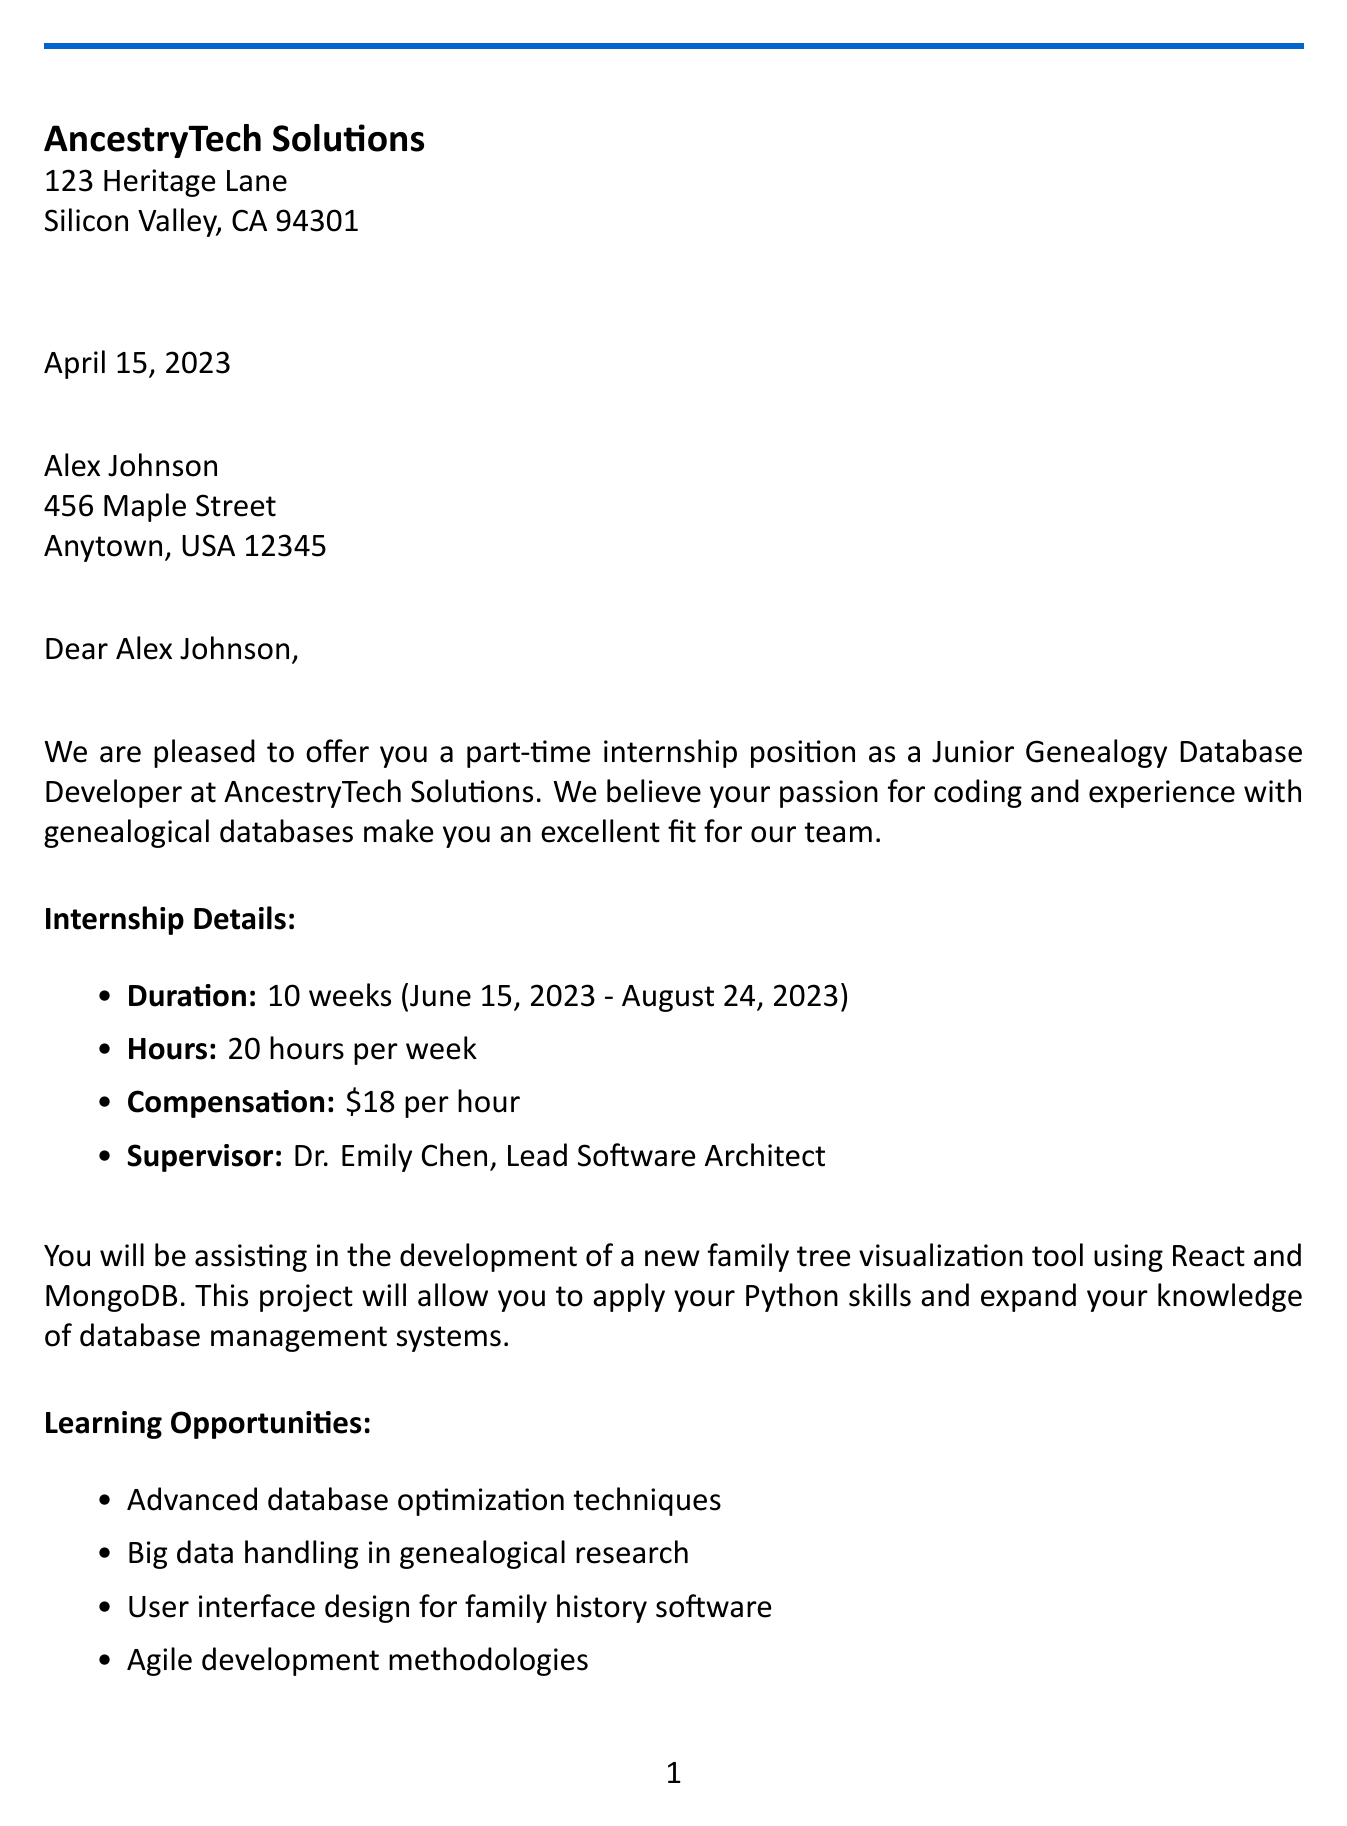What is the company name? The company name is stated at the beginning of the document as AncestryTech Solutions.
Answer: AncestryTech Solutions What is the internship title? The title of the internship is mentioned in the internship details section of the letter.
Answer: Junior Genealogy Database Developer What are the required skills? The required skills are listed in a bulleted format, including proficiency in Python and basic understanding of database management systems.
Answer: Proficiency in Python, Basic understanding of database management systems, Familiarity with version control (Git), Interest in genealogy and family history research What is the hourly rate for the internship? The letter specifies the compensation rate per hour, which is clearly stated in the internship details.
Answer: $18 per hour Who is the internship supervisor? The supervisor's name and title are provided in the internship details section.
Answer: Dr. Emily Chen How long is the duration of the internship? The letter specifies the duration of the internship as a span of weeks.
Answer: 10 weeks When is the orientation date? The date for the orientation is mentioned under the onboarding details.
Answer: June 15, 2023 What documents are required for onboarding? The document mentions a list of required documents to bring on the first day during onboarding.
Answer: Signed internship agreement, Copy of student ID, Proof of eligibility to work in the United States What is the acceptance deadline for the internship offer? The acceptance deadline is clearly stated at the end of the letter as a date.
Answer: May 1, 2023 